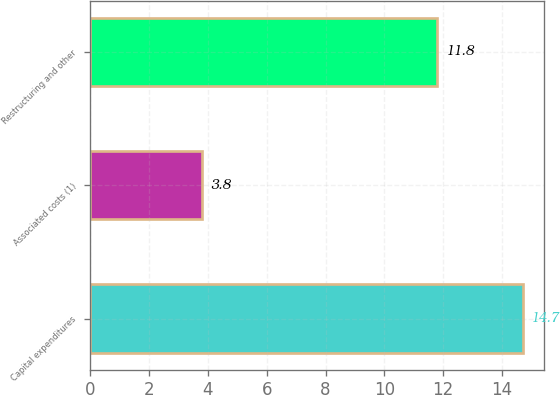Convert chart to OTSL. <chart><loc_0><loc_0><loc_500><loc_500><bar_chart><fcel>Capital expenditures<fcel>Associated costs (1)<fcel>Restructuring and other<nl><fcel>14.7<fcel>3.8<fcel>11.8<nl></chart> 